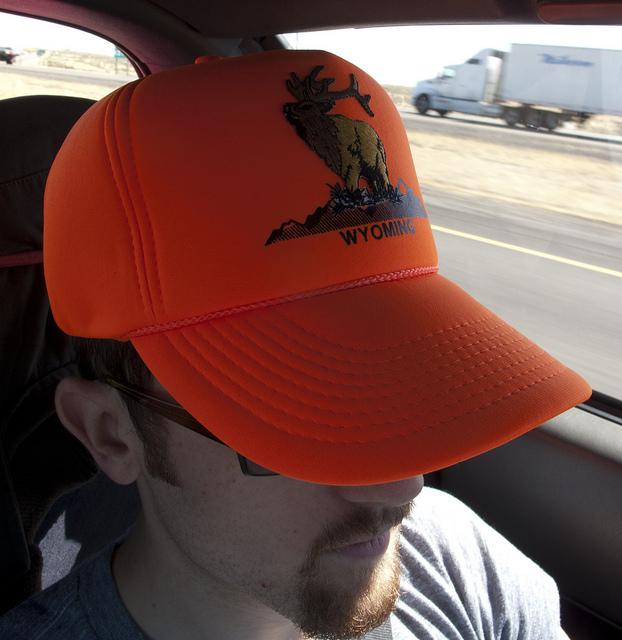Is the man wearing glasses?
Keep it brief. Yes. What type of orange is this hat?
Keep it brief. Dark. What is in the background on the other side of the road?
Keep it brief. Truck. 